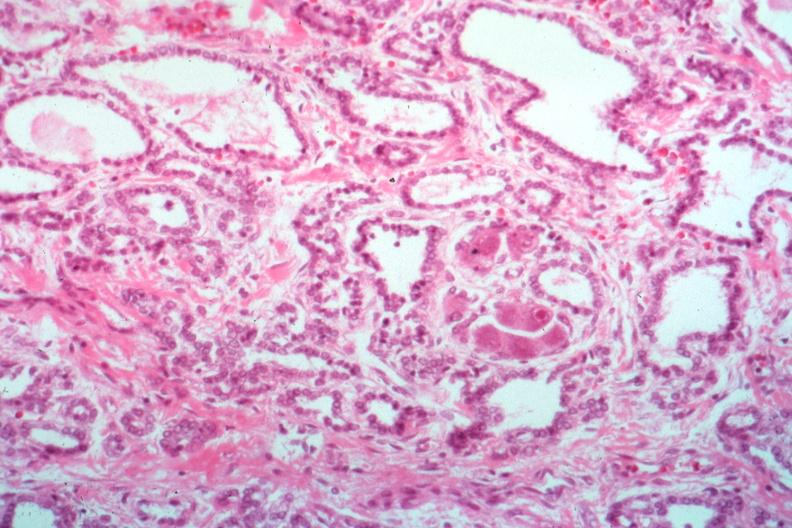what is present?
Answer the question using a single word or phrase. Endocrine 